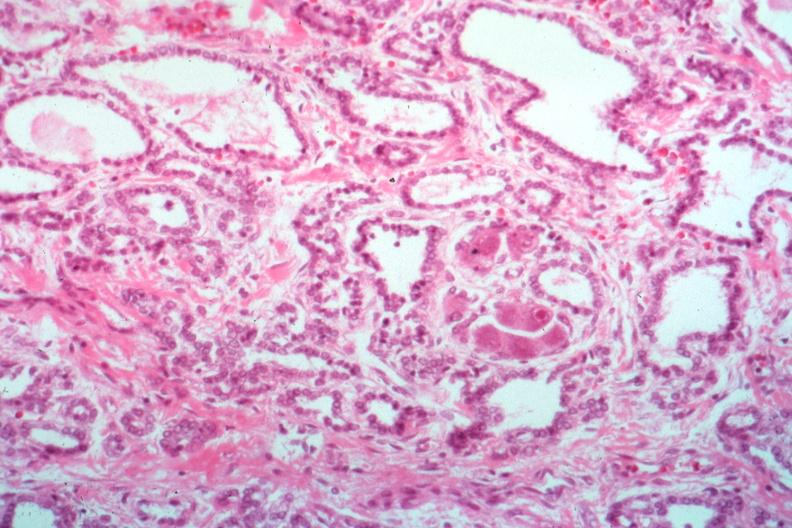what is present?
Answer the question using a single word or phrase. Endocrine 